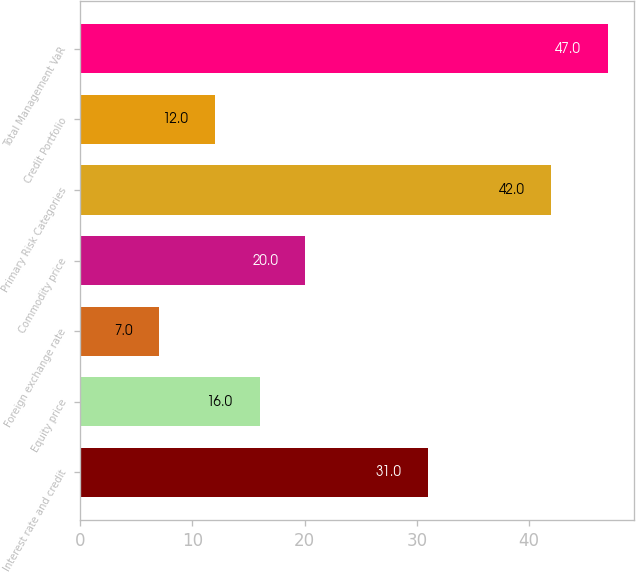Convert chart. <chart><loc_0><loc_0><loc_500><loc_500><bar_chart><fcel>Interest rate and credit<fcel>Equity price<fcel>Foreign exchange rate<fcel>Commodity price<fcel>Primary Risk Categories<fcel>Credit Portfolio<fcel>Total Management VaR<nl><fcel>31<fcel>16<fcel>7<fcel>20<fcel>42<fcel>12<fcel>47<nl></chart> 